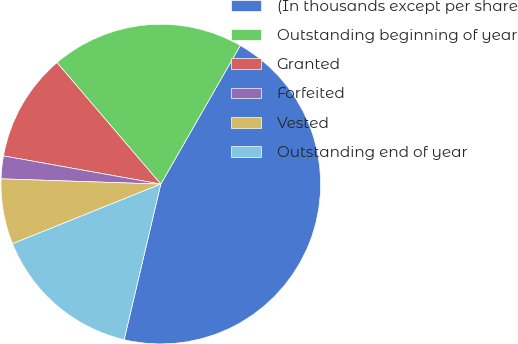<chart> <loc_0><loc_0><loc_500><loc_500><pie_chart><fcel>(In thousands except per share<fcel>Outstanding beginning of year<fcel>Granted<fcel>Forfeited<fcel>Vested<fcel>Outstanding end of year<nl><fcel>45.39%<fcel>19.54%<fcel>10.92%<fcel>2.3%<fcel>6.61%<fcel>15.23%<nl></chart> 